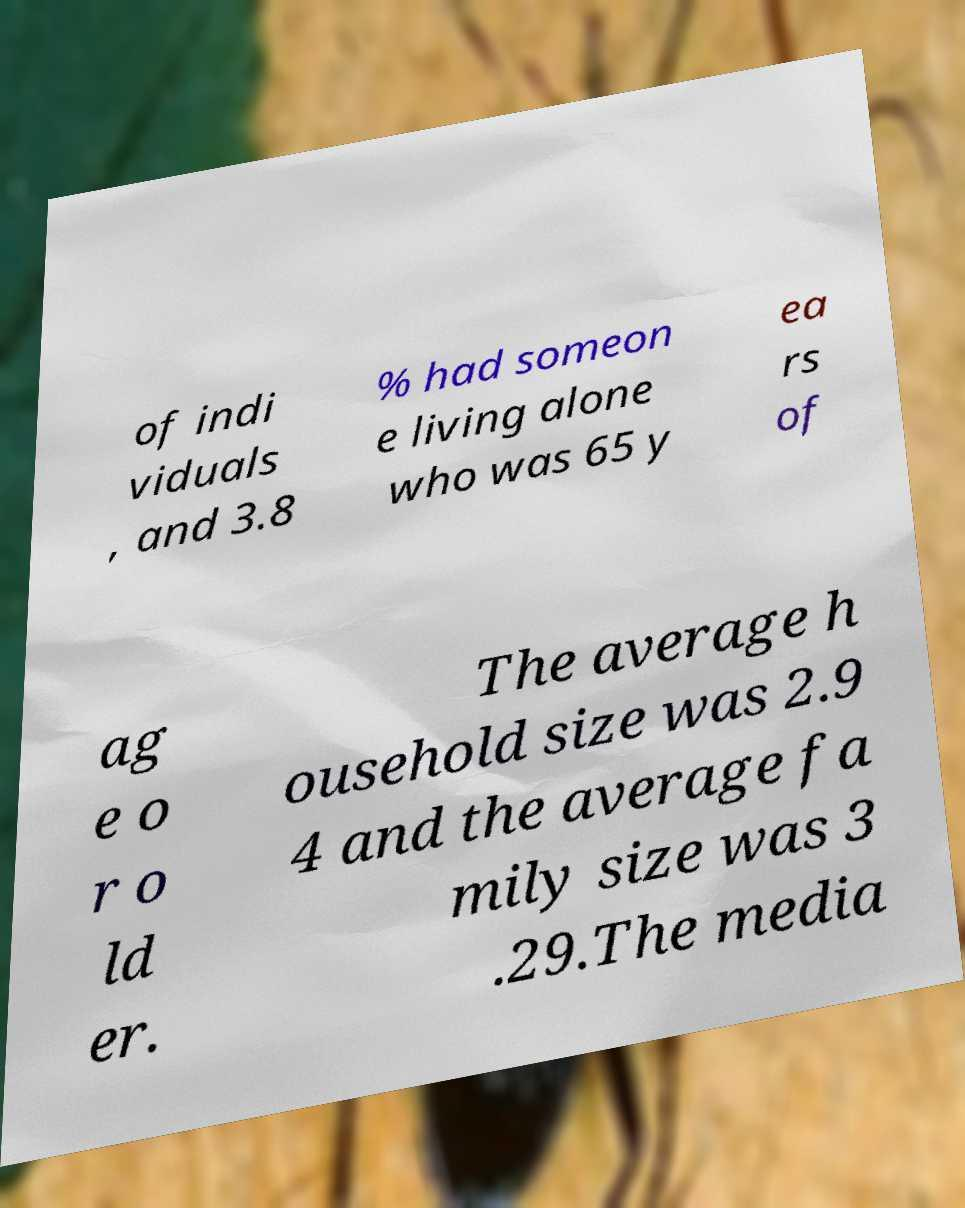Could you assist in decoding the text presented in this image and type it out clearly? of indi viduals , and 3.8 % had someon e living alone who was 65 y ea rs of ag e o r o ld er. The average h ousehold size was 2.9 4 and the average fa mily size was 3 .29.The media 